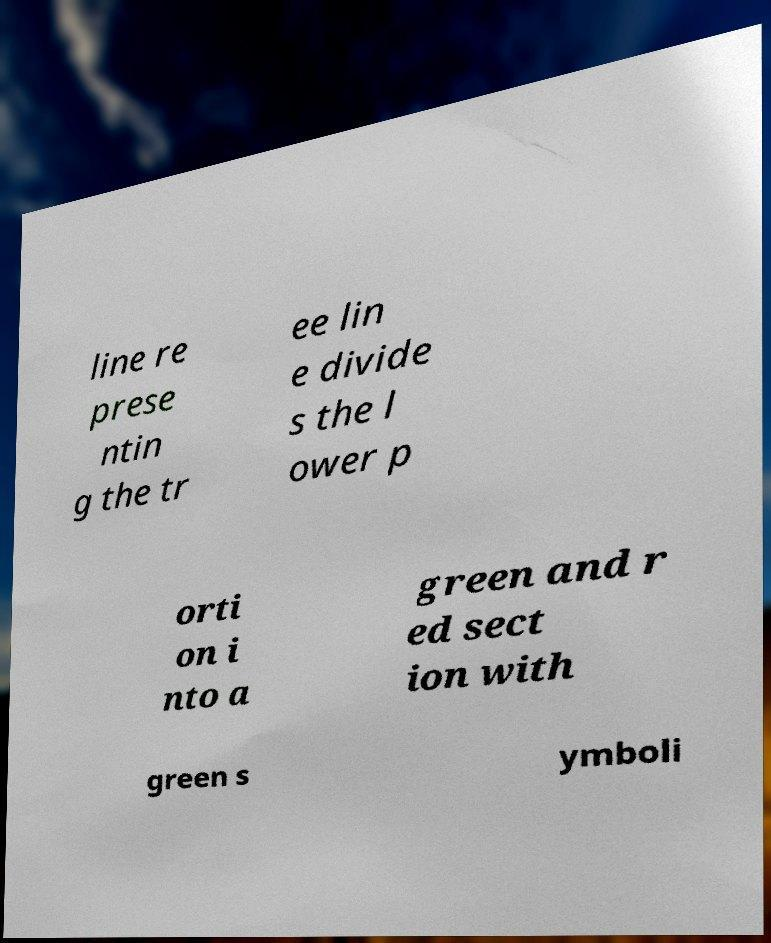Could you extract and type out the text from this image? line re prese ntin g the tr ee lin e divide s the l ower p orti on i nto a green and r ed sect ion with green s ymboli 